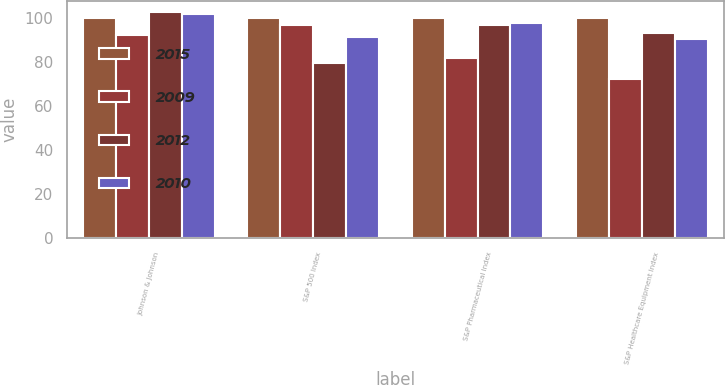Convert chart to OTSL. <chart><loc_0><loc_0><loc_500><loc_500><stacked_bar_chart><ecel><fcel>Johnson & Johnson<fcel>S&P 500 Index<fcel>S&P Pharmaceutical Index<fcel>S&P Healthcare Equipment Index<nl><fcel>2015<fcel>100<fcel>100<fcel>100<fcel>100<nl><fcel>2009<fcel>92.23<fcel>97.03<fcel>81.8<fcel>72.36<nl><fcel>2012<fcel>102.63<fcel>79.66<fcel>97.03<fcel>93.19<nl><fcel>2010<fcel>102.03<fcel>91.66<fcel>97.78<fcel>90.66<nl></chart> 